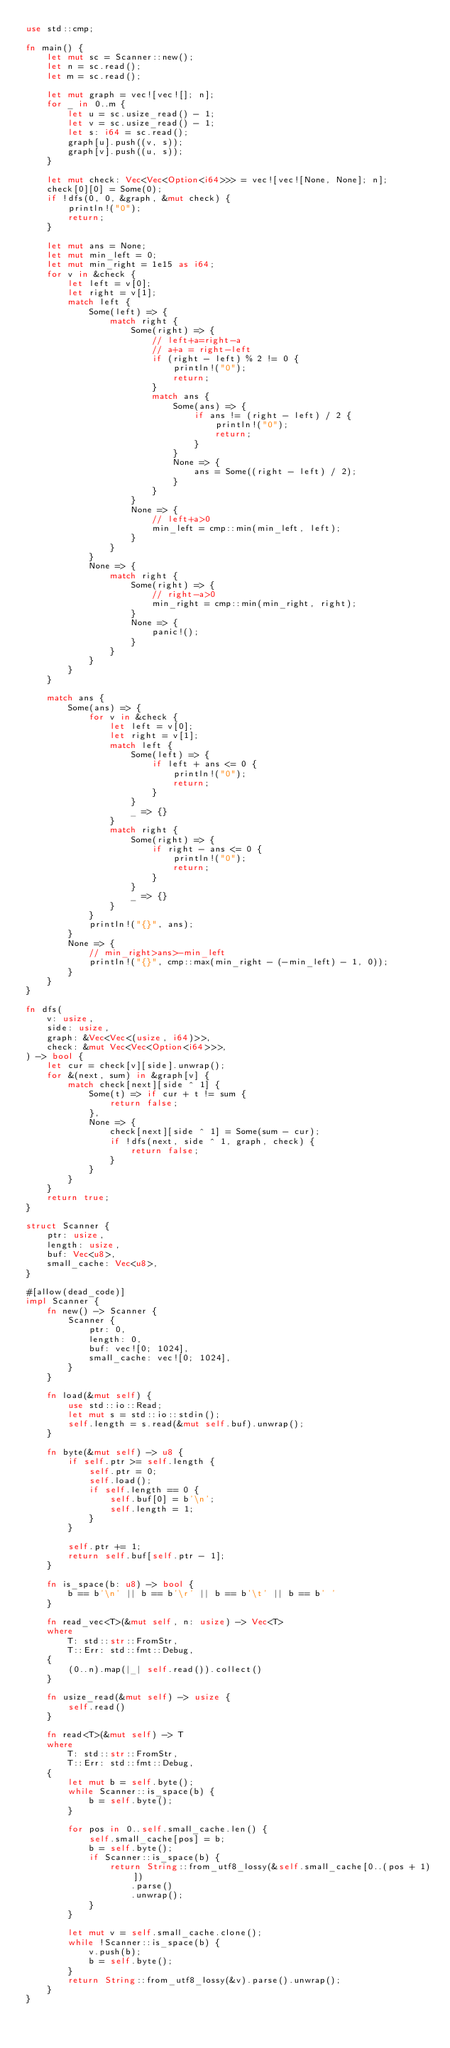<code> <loc_0><loc_0><loc_500><loc_500><_Rust_>use std::cmp;

fn main() {
    let mut sc = Scanner::new();
    let n = sc.read();
    let m = sc.read();

    let mut graph = vec![vec![]; n];
    for _ in 0..m {
        let u = sc.usize_read() - 1;
        let v = sc.usize_read() - 1;
        let s: i64 = sc.read();
        graph[u].push((v, s));
        graph[v].push((u, s));
    }

    let mut check: Vec<Vec<Option<i64>>> = vec![vec![None, None]; n];
    check[0][0] = Some(0);
    if !dfs(0, 0, &graph, &mut check) {
        println!("0");
        return;
    }

    let mut ans = None;
    let mut min_left = 0;
    let mut min_right = 1e15 as i64;
    for v in &check {
        let left = v[0];
        let right = v[1];
        match left {
            Some(left) => {
                match right {
                    Some(right) => {
                        // left+a=right-a
                        // a+a = right-left
                        if (right - left) % 2 != 0 {
                            println!("0");
                            return;
                        }
                        match ans {
                            Some(ans) => {
                                if ans != (right - left) / 2 {
                                    println!("0");
                                    return;
                                }
                            }
                            None => {
                                ans = Some((right - left) / 2);
                            }
                        }
                    }
                    None => {
                        // left+a>0
                        min_left = cmp::min(min_left, left);
                    }
                }
            }
            None => {
                match right {
                    Some(right) => {
                        // right-a>0
                        min_right = cmp::min(min_right, right);
                    }
                    None => {
                        panic!();
                    }
                }
            }
        }
    }

    match ans {
        Some(ans) => {
            for v in &check {
                let left = v[0];
                let right = v[1];
                match left {
                    Some(left) => {
                        if left + ans <= 0 {
                            println!("0");
                            return;
                        }
                    }
                    _ => {}
                }
                match right {
                    Some(right) => {
                        if right - ans <= 0 {
                            println!("0");
                            return;
                        }
                    }
                    _ => {}
                }
            }
            println!("{}", ans);
        }
        None => {
            // min_right>ans>-min_left
            println!("{}", cmp::max(min_right - (-min_left) - 1, 0));
        }
    }
}

fn dfs(
    v: usize,
    side: usize,
    graph: &Vec<Vec<(usize, i64)>>,
    check: &mut Vec<Vec<Option<i64>>>,
) -> bool {
    let cur = check[v][side].unwrap();
    for &(next, sum) in &graph[v] {
        match check[next][side ^ 1] {
            Some(t) => if cur + t != sum {
                return false;
            },
            None => {
                check[next][side ^ 1] = Some(sum - cur);
                if !dfs(next, side ^ 1, graph, check) {
                    return false;
                }
            }
        }
    }
    return true;
}

struct Scanner {
    ptr: usize,
    length: usize,
    buf: Vec<u8>,
    small_cache: Vec<u8>,
}

#[allow(dead_code)]
impl Scanner {
    fn new() -> Scanner {
        Scanner {
            ptr: 0,
            length: 0,
            buf: vec![0; 1024],
            small_cache: vec![0; 1024],
        }
    }

    fn load(&mut self) {
        use std::io::Read;
        let mut s = std::io::stdin();
        self.length = s.read(&mut self.buf).unwrap();
    }

    fn byte(&mut self) -> u8 {
        if self.ptr >= self.length {
            self.ptr = 0;
            self.load();
            if self.length == 0 {
                self.buf[0] = b'\n';
                self.length = 1;
            }
        }

        self.ptr += 1;
        return self.buf[self.ptr - 1];
    }

    fn is_space(b: u8) -> bool {
        b == b'\n' || b == b'\r' || b == b'\t' || b == b' '
    }

    fn read_vec<T>(&mut self, n: usize) -> Vec<T>
    where
        T: std::str::FromStr,
        T::Err: std::fmt::Debug,
    {
        (0..n).map(|_| self.read()).collect()
    }

    fn usize_read(&mut self) -> usize {
        self.read()
    }

    fn read<T>(&mut self) -> T
    where
        T: std::str::FromStr,
        T::Err: std::fmt::Debug,
    {
        let mut b = self.byte();
        while Scanner::is_space(b) {
            b = self.byte();
        }

        for pos in 0..self.small_cache.len() {
            self.small_cache[pos] = b;
            b = self.byte();
            if Scanner::is_space(b) {
                return String::from_utf8_lossy(&self.small_cache[0..(pos + 1)])
                    .parse()
                    .unwrap();
            }
        }

        let mut v = self.small_cache.clone();
        while !Scanner::is_space(b) {
            v.push(b);
            b = self.byte();
        }
        return String::from_utf8_lossy(&v).parse().unwrap();
    }
}
</code> 